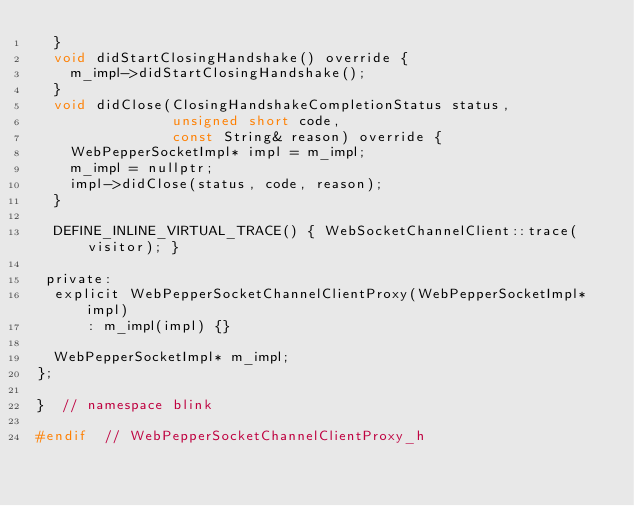<code> <loc_0><loc_0><loc_500><loc_500><_C_>  }
  void didStartClosingHandshake() override {
    m_impl->didStartClosingHandshake();
  }
  void didClose(ClosingHandshakeCompletionStatus status,
                unsigned short code,
                const String& reason) override {
    WebPepperSocketImpl* impl = m_impl;
    m_impl = nullptr;
    impl->didClose(status, code, reason);
  }

  DEFINE_INLINE_VIRTUAL_TRACE() { WebSocketChannelClient::trace(visitor); }

 private:
  explicit WebPepperSocketChannelClientProxy(WebPepperSocketImpl* impl)
      : m_impl(impl) {}

  WebPepperSocketImpl* m_impl;
};

}  // namespace blink

#endif  // WebPepperSocketChannelClientProxy_h
</code> 